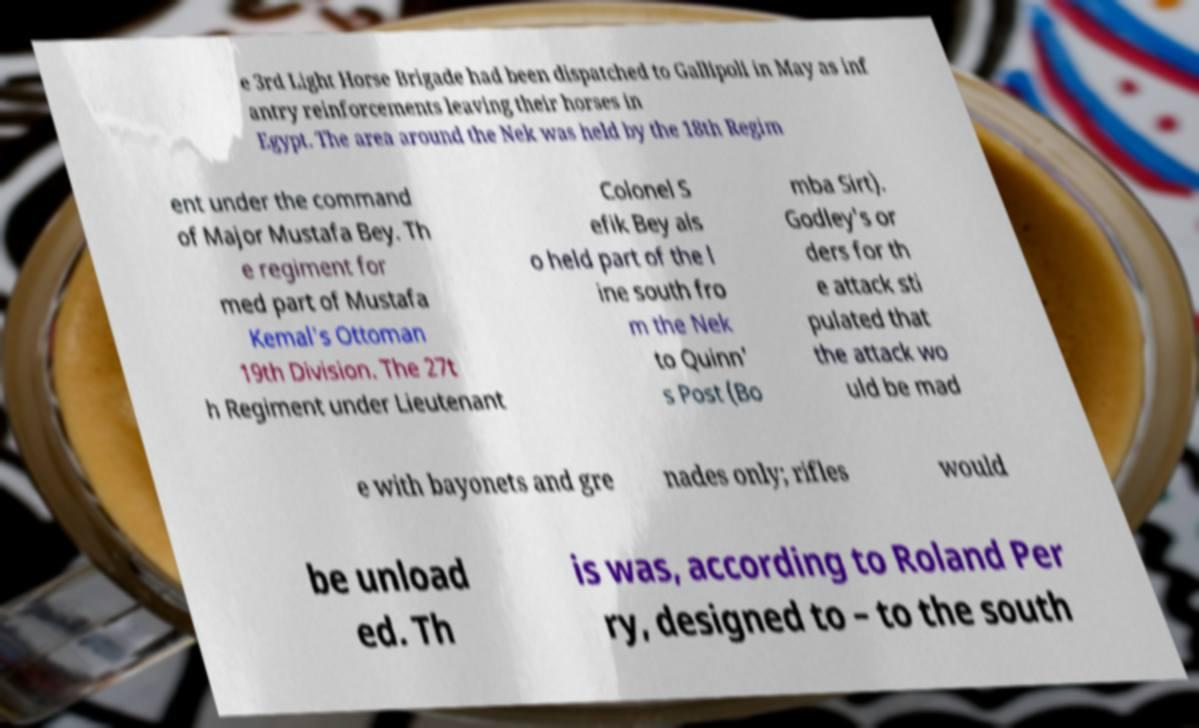Could you assist in decoding the text presented in this image and type it out clearly? e 3rd Light Horse Brigade had been dispatched to Gallipoli in May as inf antry reinforcements leaving their horses in Egypt. The area around the Nek was held by the 18th Regim ent under the command of Major Mustafa Bey. Th e regiment for med part of Mustafa Kemal's Ottoman 19th Division. The 27t h Regiment under Lieutenant Colonel S efik Bey als o held part of the l ine south fro m the Nek to Quinn' s Post (Bo mba Sirt). Godley's or ders for th e attack sti pulated that the attack wo uld be mad e with bayonets and gre nades only; rifles would be unload ed. Th is was, according to Roland Per ry, designed to – to the south 